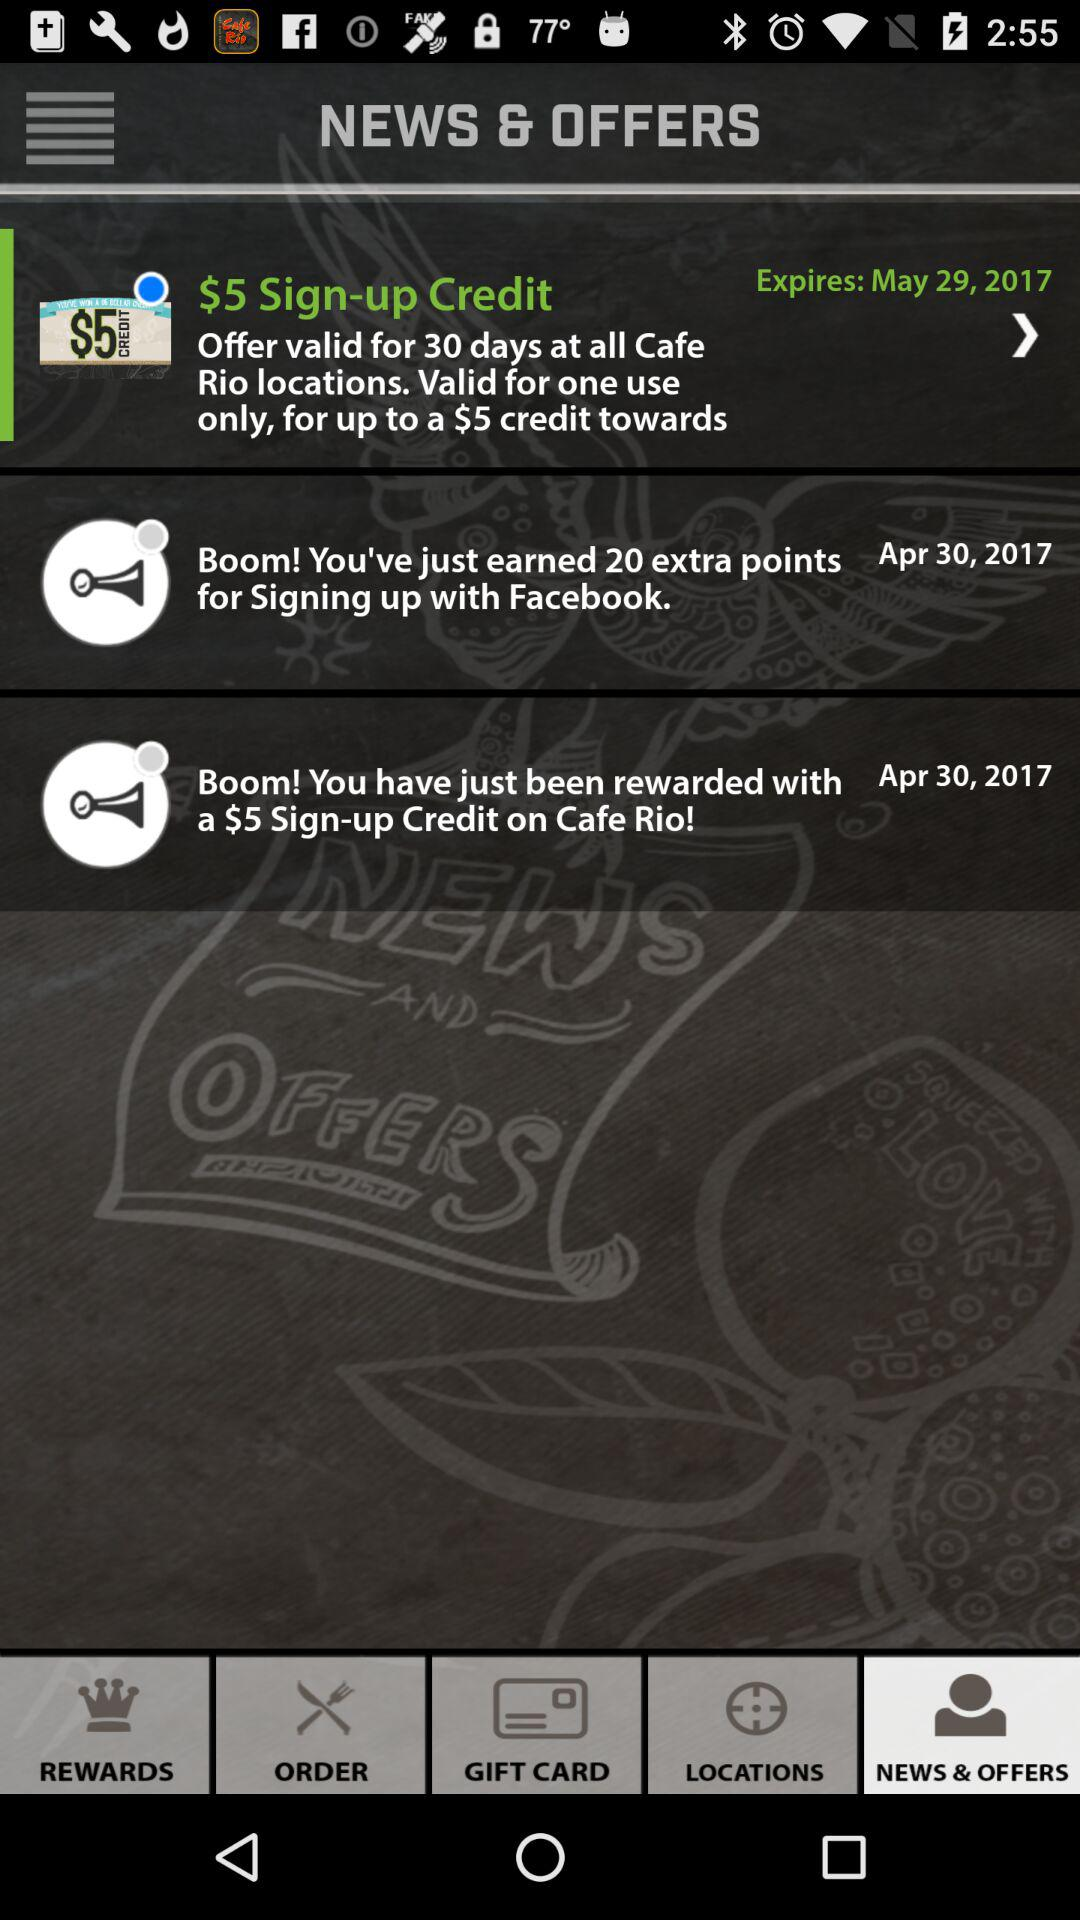How many offers have expired?
Answer the question using a single word or phrase. 1 